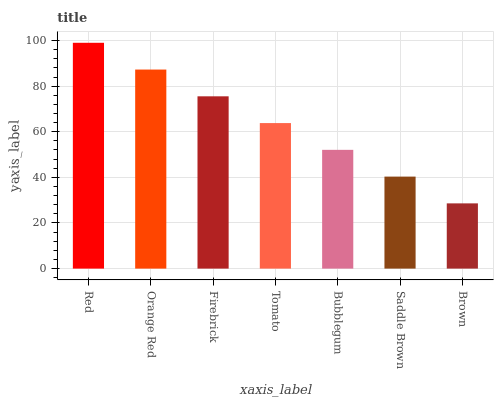Is Brown the minimum?
Answer yes or no. Yes. Is Red the maximum?
Answer yes or no. Yes. Is Orange Red the minimum?
Answer yes or no. No. Is Orange Red the maximum?
Answer yes or no. No. Is Red greater than Orange Red?
Answer yes or no. Yes. Is Orange Red less than Red?
Answer yes or no. Yes. Is Orange Red greater than Red?
Answer yes or no. No. Is Red less than Orange Red?
Answer yes or no. No. Is Tomato the high median?
Answer yes or no. Yes. Is Tomato the low median?
Answer yes or no. Yes. Is Firebrick the high median?
Answer yes or no. No. Is Brown the low median?
Answer yes or no. No. 